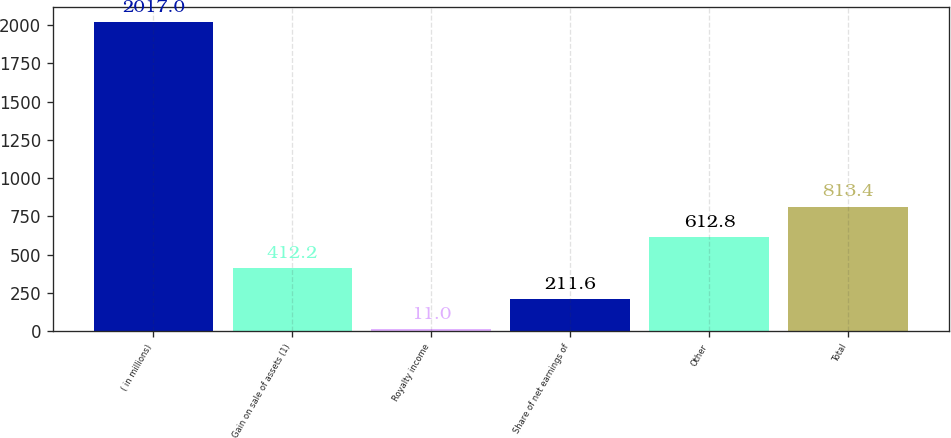Convert chart. <chart><loc_0><loc_0><loc_500><loc_500><bar_chart><fcel>( in millions)<fcel>Gain on sale of assets (1)<fcel>Royalty income<fcel>Share of net earnings of<fcel>Other<fcel>Total<nl><fcel>2017<fcel>412.2<fcel>11<fcel>211.6<fcel>612.8<fcel>813.4<nl></chart> 